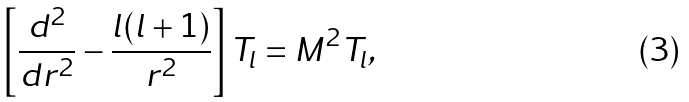Convert formula to latex. <formula><loc_0><loc_0><loc_500><loc_500>\left [ { \frac { d ^ { 2 } } { d r ^ { 2 } } } - { \frac { l ( l + 1 ) } { r ^ { 2 } } } \right ] T _ { l } = M ^ { 2 } T _ { l } ,</formula> 